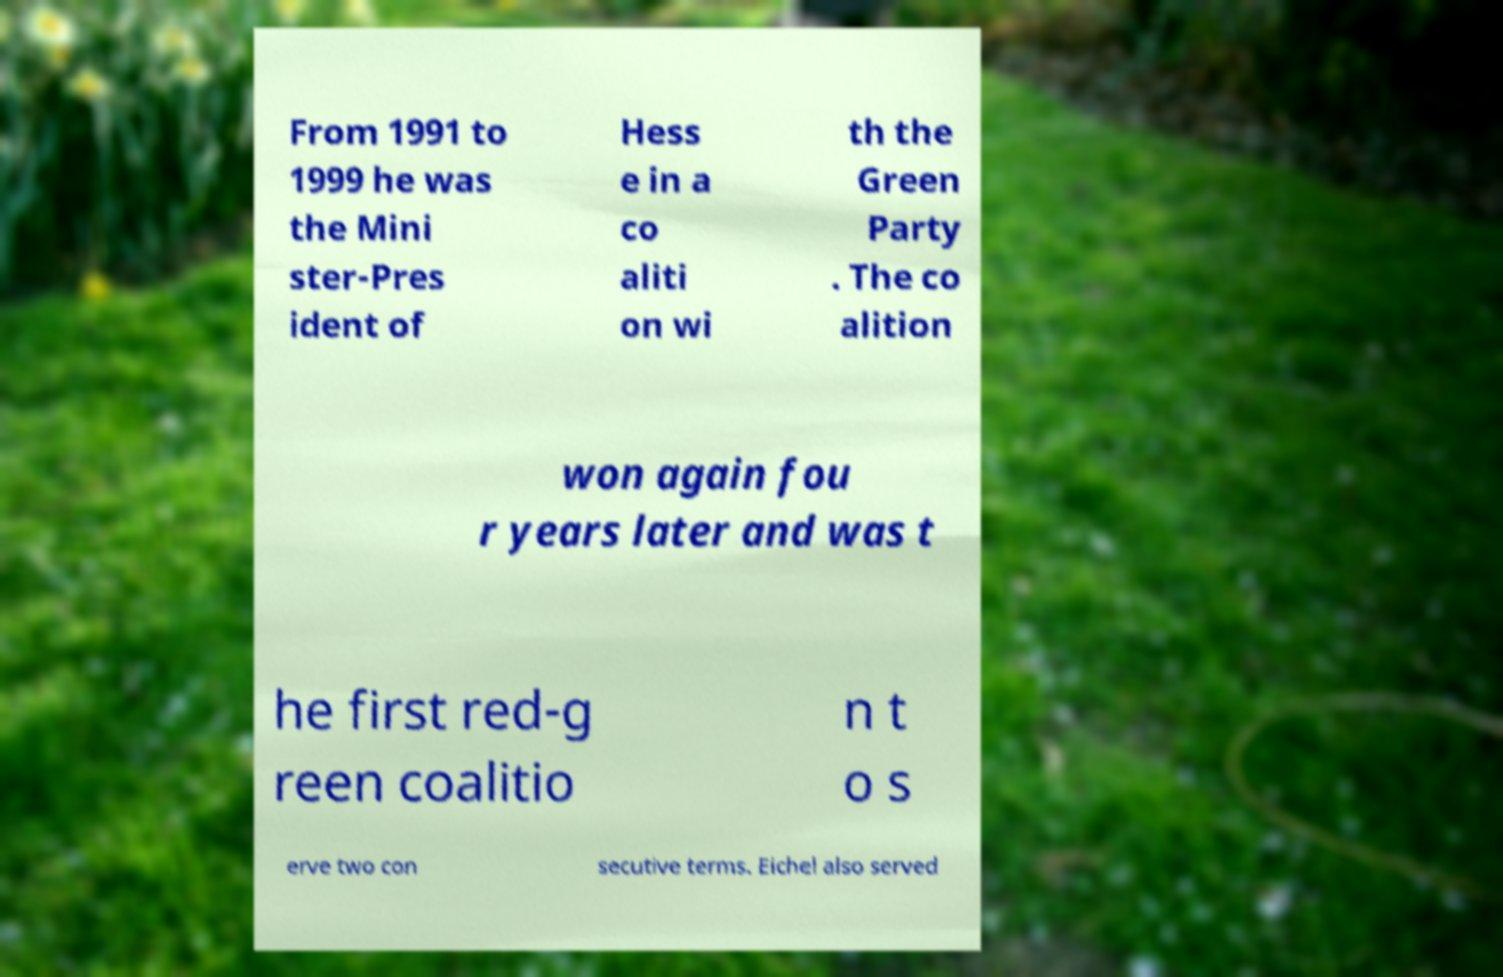Could you assist in decoding the text presented in this image and type it out clearly? From 1991 to 1999 he was the Mini ster-Pres ident of Hess e in a co aliti on wi th the Green Party . The co alition won again fou r years later and was t he first red-g reen coalitio n t o s erve two con secutive terms. Eichel also served 